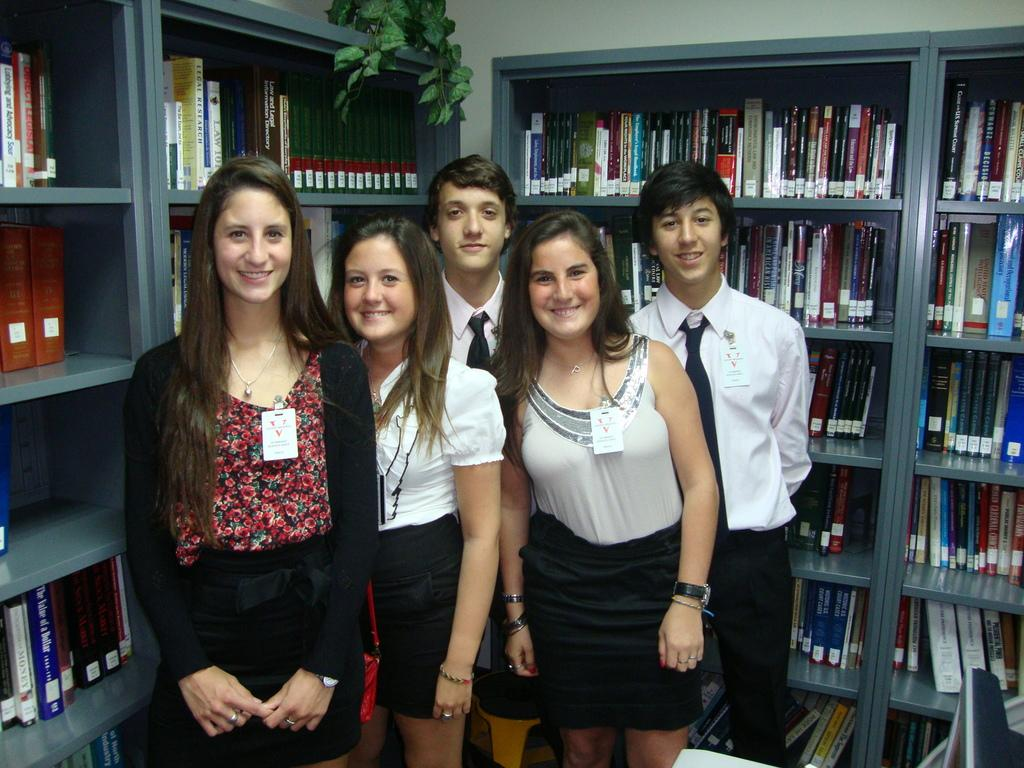What can be seen in the image involving people? There are people standing in the image. What items are visible that might be used for identification? ID cards are visible in the image. What type of storage is present for holding books? There are books on bookshelves in the image. What type of vegetation is present in the image? There is a plant in the image. What type of electronic device is present on a table? There is a monitor on a table in the image. What type of ink is being used to smash the balls in the image? There is no ink, smashing, or balls present in the image. 